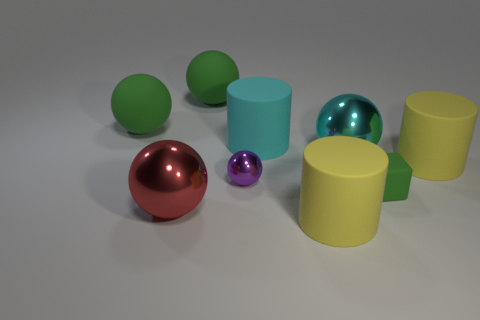How many yellow cylinders must be subtracted to get 1 yellow cylinders? 1 Subtract all yellow rubber cylinders. How many cylinders are left? 1 Subtract all red cubes. How many yellow cylinders are left? 2 Add 1 cyan metal objects. How many objects exist? 10 Subtract 2 spheres. How many spheres are left? 3 Subtract all red spheres. How many spheres are left? 4 Subtract all cubes. How many objects are left? 8 Subtract all purple cylinders. Subtract all red spheres. How many cylinders are left? 3 Add 2 rubber things. How many rubber things exist? 8 Subtract 1 green blocks. How many objects are left? 8 